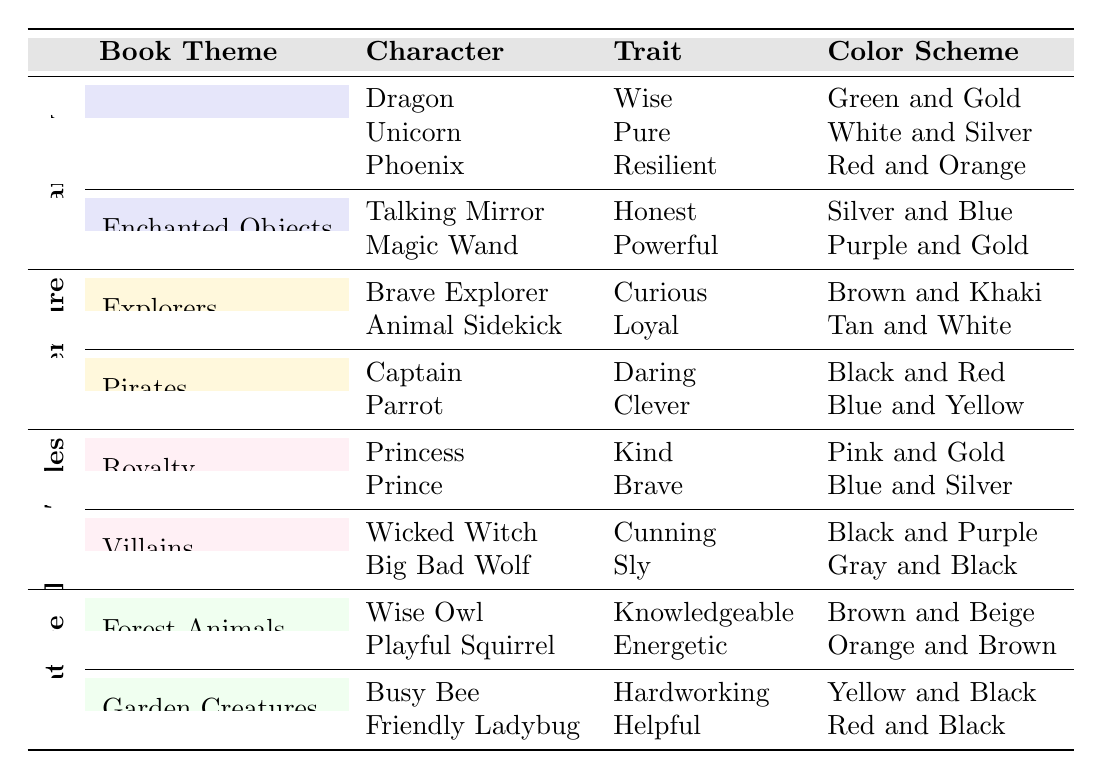What trait does the Dragon have? The Dragon is listed under the "Magical Creatures" category in the "Fantasy" theme, and its trait is "Wise."
Answer: Wise Which character is associated with the color scheme "Red and Black"? The table indicates that the "Friendly Ladybug" has a color scheme of "Red and Black," found in the "Garden Creatures" category of the "Nature" theme.
Answer: Friendly Ladybug How many traits are represented in the "Pirates" category? The "Pirates" category includes two characters: Captain and Parrot. Each character has a distinct trait, which totals up to two traits.
Answer: 2 Is the Unicorn's trait related to courage? The Unicorn's trait is "Pure," which is not directly related to courage; therefore, it is false.
Answer: No Which character in the "Royalty" category has a color scheme of "Pink and Gold"? The Princess is listed in the "Royalty" category of the "Fairy Tales" theme, and her color scheme is "Pink and Gold."
Answer: Princess Which theme has the most characters in it? By examining the table, the "Fantasy" theme has five characters total: three from "Magical Creatures" and two from "Enchanted Objects." The "Adventure" theme has four characters, while both "Fairy Tales" and "Nature" have four. Thus, "Fantasy" has the most characters.
Answer: Fantasy What is the color scheme of the Talking Mirror? The Talking Mirror, located under "Enchanted Objects" in the "Fantasy" category, has a color scheme of "Silver and Blue."
Answer: Silver and Blue Which character trait appears most frequently among the characters listed in the table? To ascertain this, we can list the traits: Wise, Pure, Resilient, Honest, Powerful, Curious, Loyal, Daring, Clever, Kind, Brave, Cunning, Sly, Knowledgeable, Energetic, Hardworking, Helpful. None of these traits repeats, thus no trait appears more than once.
Answer: None What is the total number of characters listed in the "Nature" theme? The "Nature" theme includes four characters: Wise Owl and Playful Squirrel from "Forest Animals," and Busy Bee and Friendly Ladybug from "Garden Creatures." Therefore, the total is four.
Answer: 4 Which character among "Villains" is described as "Cunning"? The "Wicked Witch" is listed under the "Villains" category in the "Fairy Tales" theme, and her trait is "Cunning."
Answer: Wicked Witch 